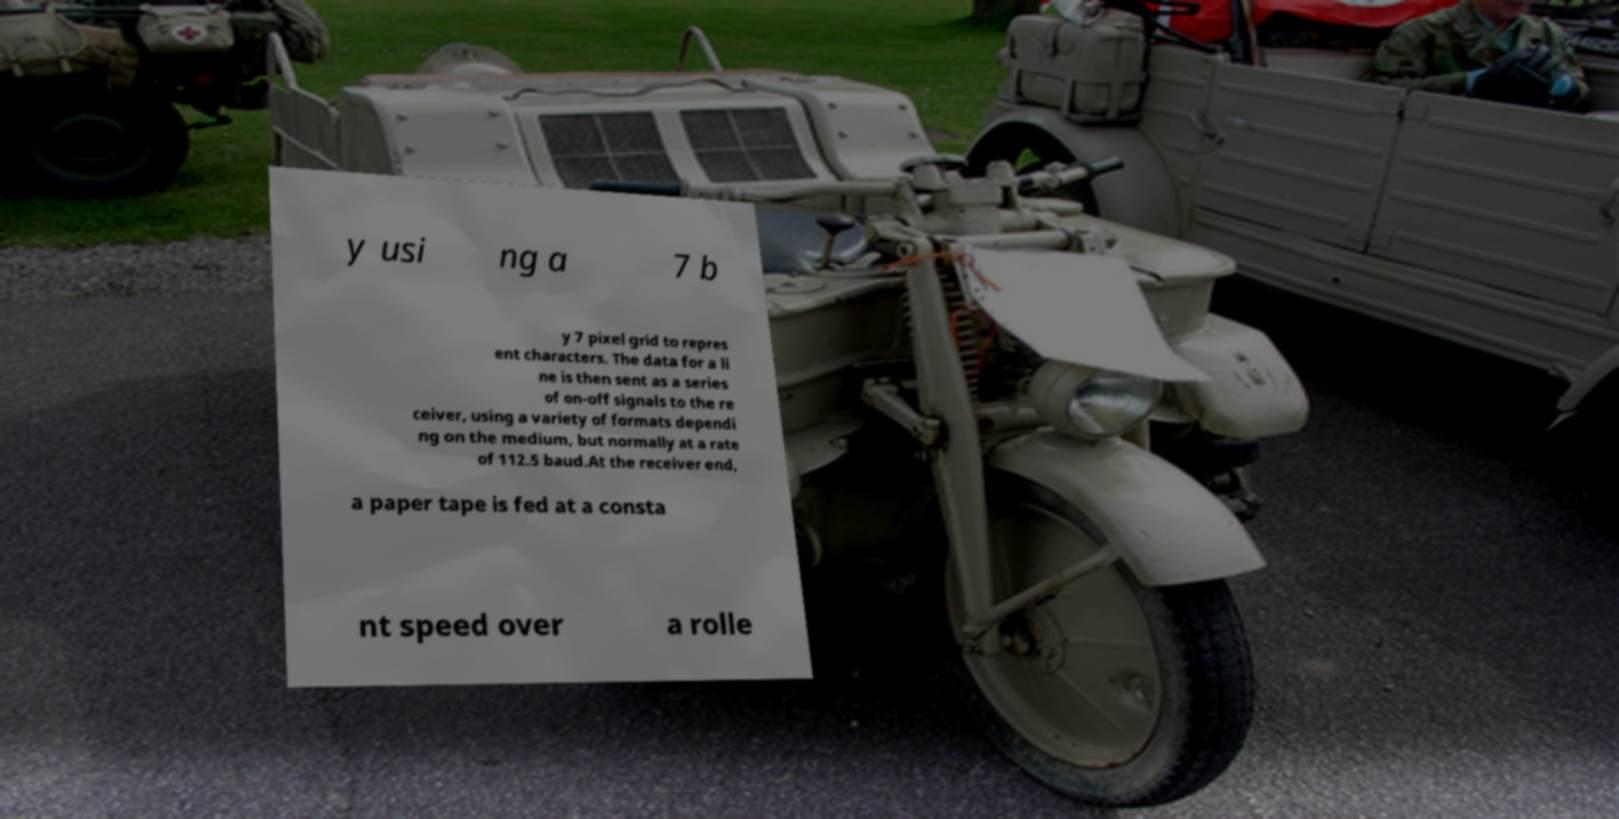Could you extract and type out the text from this image? y usi ng a 7 b y 7 pixel grid to repres ent characters. The data for a li ne is then sent as a series of on-off signals to the re ceiver, using a variety of formats dependi ng on the medium, but normally at a rate of 112.5 baud.At the receiver end, a paper tape is fed at a consta nt speed over a rolle 